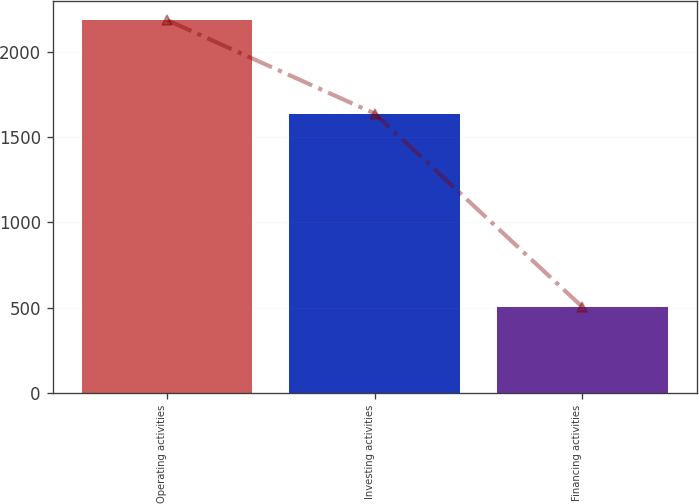Convert chart. <chart><loc_0><loc_0><loc_500><loc_500><bar_chart><fcel>Operating activities<fcel>Investing activities<fcel>Financing activities<nl><fcel>2186.4<fcel>1638<fcel>504.3<nl></chart> 